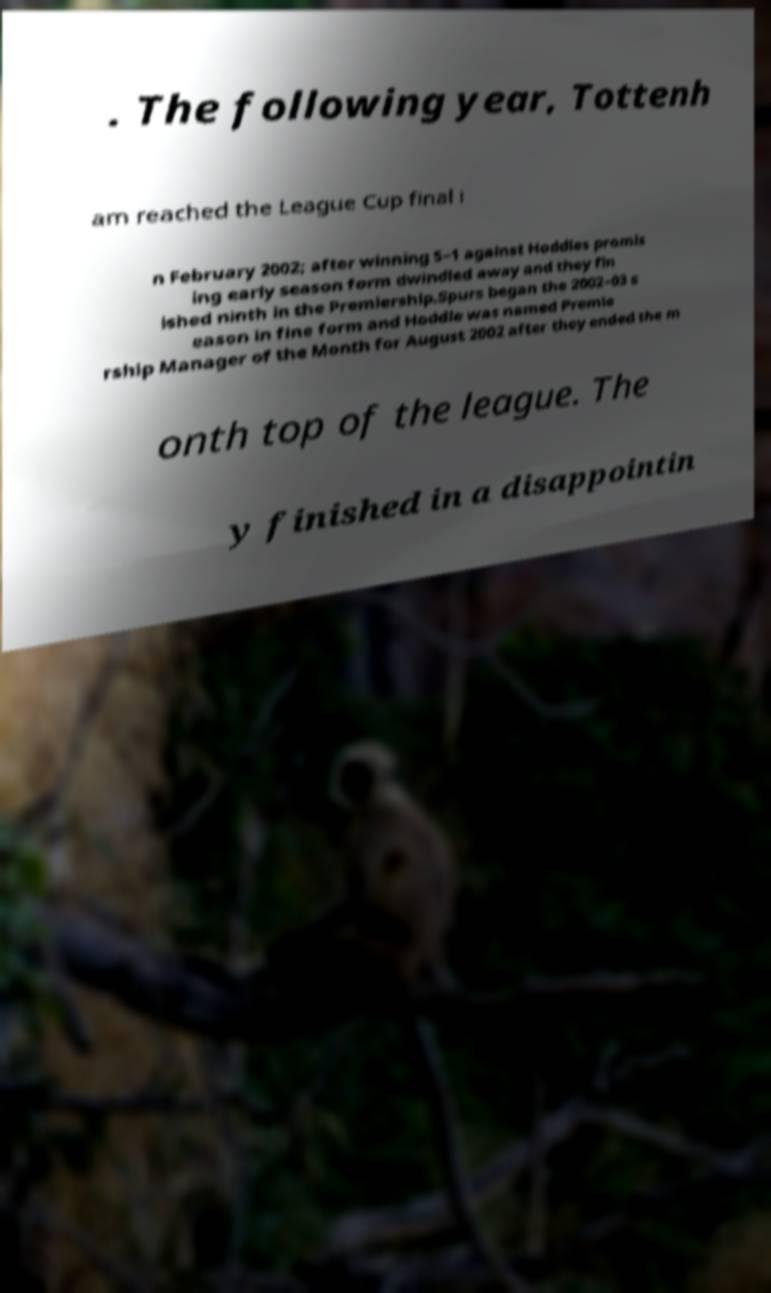There's text embedded in this image that I need extracted. Can you transcribe it verbatim? . The following year, Tottenh am reached the League Cup final i n February 2002; after winning 5–1 against Hoddles promis ing early season form dwindled away and they fin ished ninth in the Premiership.Spurs began the 2002–03 s eason in fine form and Hoddle was named Premie rship Manager of the Month for August 2002 after they ended the m onth top of the league. The y finished in a disappointin 